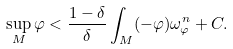<formula> <loc_0><loc_0><loc_500><loc_500>\sup _ { M } \varphi < \frac { 1 - \delta } { \delta } \int _ { M } ( - \varphi ) \omega _ { \varphi } ^ { n } + C .</formula> 